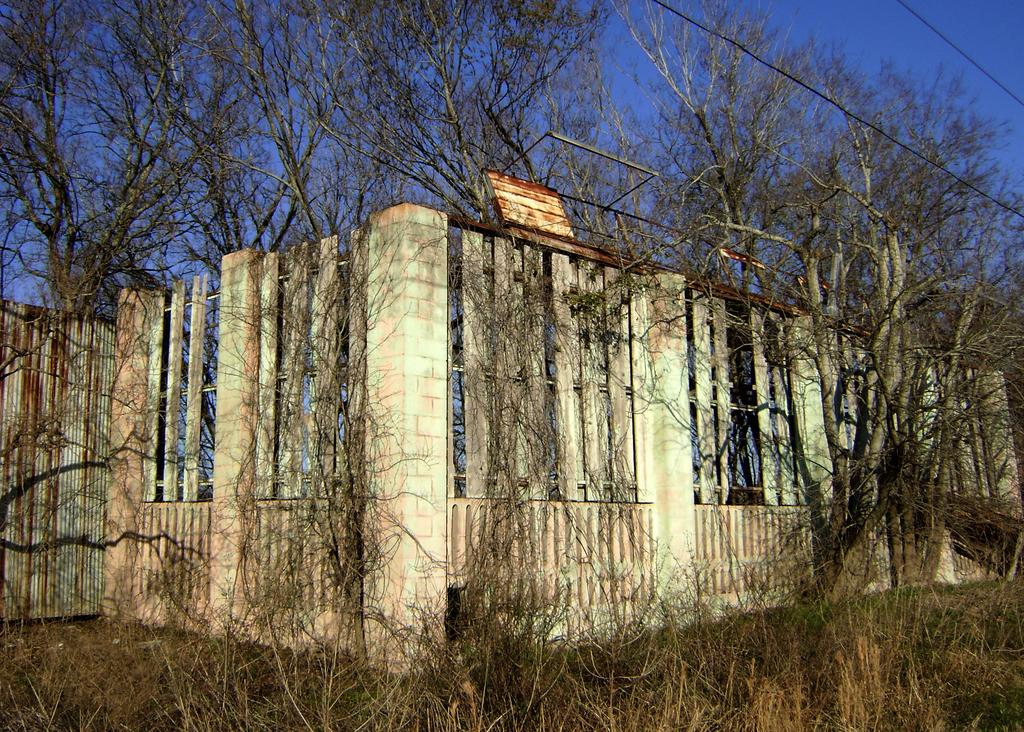What separates the two sides of the image? There is a boundary in the center of the image. What type of vegetation can be seen in the image? There is greenery in the image. How many pizzas are stacked on the knee in the image? There are no pizzas or knees present in the image. What type of beam is supporting the greenery in the image? There is no beam present in the image; the greenery is not supported by any visible structure. 